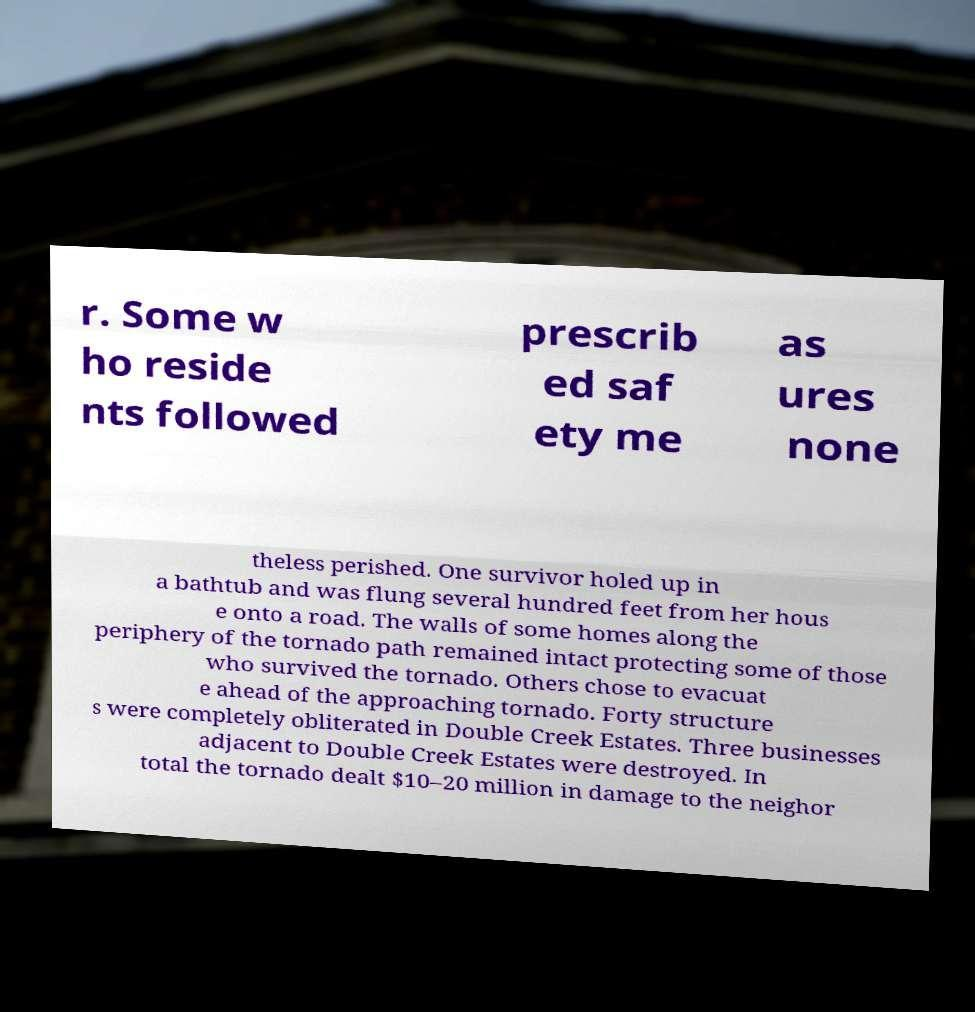There's text embedded in this image that I need extracted. Can you transcribe it verbatim? r. Some w ho reside nts followed prescrib ed saf ety me as ures none theless perished. One survivor holed up in a bathtub and was flung several hundred feet from her hous e onto a road. The walls of some homes along the periphery of the tornado path remained intact protecting some of those who survived the tornado. Others chose to evacuat e ahead of the approaching tornado. Forty structure s were completely obliterated in Double Creek Estates. Three businesses adjacent to Double Creek Estates were destroyed. In total the tornado dealt $10–20 million in damage to the neighor 